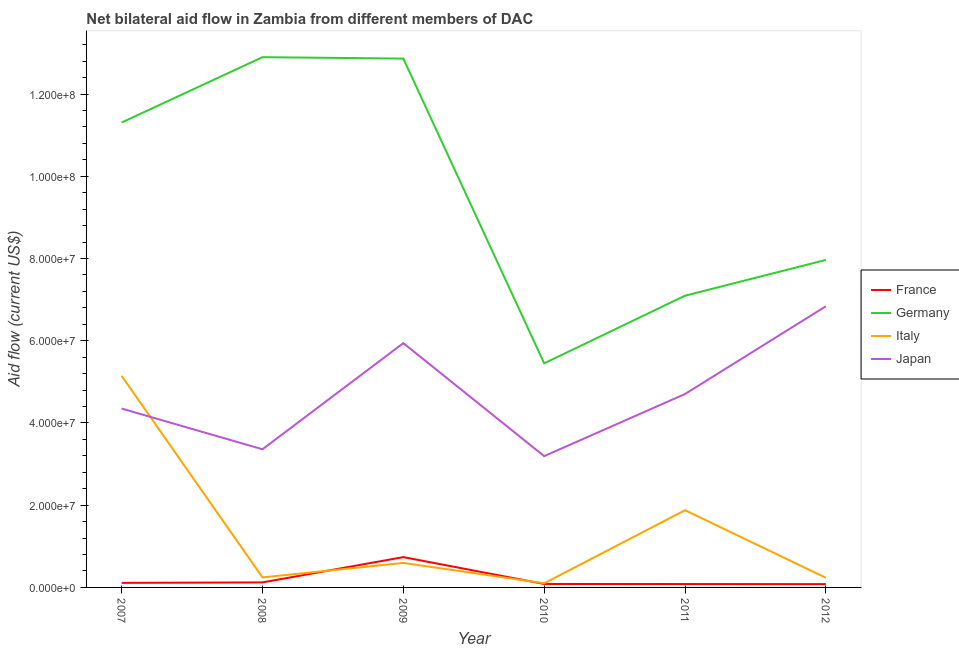How many different coloured lines are there?
Offer a terse response. 4. Does the line corresponding to amount of aid given by japan intersect with the line corresponding to amount of aid given by italy?
Provide a short and direct response. Yes. Is the number of lines equal to the number of legend labels?
Give a very brief answer. Yes. What is the amount of aid given by italy in 2007?
Provide a succinct answer. 5.14e+07. Across all years, what is the maximum amount of aid given by france?
Offer a very short reply. 7.37e+06. Across all years, what is the minimum amount of aid given by japan?
Keep it short and to the point. 3.19e+07. In which year was the amount of aid given by france maximum?
Offer a very short reply. 2009. In which year was the amount of aid given by japan minimum?
Your answer should be compact. 2010. What is the total amount of aid given by germany in the graph?
Offer a very short reply. 5.76e+08. What is the difference between the amount of aid given by germany in 2007 and that in 2011?
Keep it short and to the point. 4.21e+07. What is the difference between the amount of aid given by italy in 2012 and the amount of aid given by germany in 2007?
Offer a very short reply. -1.11e+08. What is the average amount of aid given by france per year?
Make the answer very short. 2.03e+06. In the year 2007, what is the difference between the amount of aid given by japan and amount of aid given by france?
Make the answer very short. 4.24e+07. What is the ratio of the amount of aid given by france in 2010 to that in 2011?
Provide a short and direct response. 1.02. Is the difference between the amount of aid given by italy in 2007 and 2011 greater than the difference between the amount of aid given by germany in 2007 and 2011?
Ensure brevity in your answer.  No. What is the difference between the highest and the second highest amount of aid given by italy?
Your answer should be very brief. 3.27e+07. What is the difference between the highest and the lowest amount of aid given by italy?
Give a very brief answer. 5.04e+07. In how many years, is the amount of aid given by france greater than the average amount of aid given by france taken over all years?
Make the answer very short. 1. Is the sum of the amount of aid given by germany in 2009 and 2011 greater than the maximum amount of aid given by italy across all years?
Give a very brief answer. Yes. Is the amount of aid given by japan strictly greater than the amount of aid given by italy over the years?
Ensure brevity in your answer.  No. Is the amount of aid given by italy strictly less than the amount of aid given by japan over the years?
Your response must be concise. No. How many lines are there?
Provide a short and direct response. 4. How many years are there in the graph?
Provide a succinct answer. 6. Are the values on the major ticks of Y-axis written in scientific E-notation?
Provide a short and direct response. Yes. Does the graph contain any zero values?
Provide a short and direct response. No. Does the graph contain grids?
Provide a succinct answer. No. How many legend labels are there?
Provide a succinct answer. 4. What is the title of the graph?
Your answer should be very brief. Net bilateral aid flow in Zambia from different members of DAC. What is the Aid flow (current US$) in France in 2007?
Your answer should be compact. 1.11e+06. What is the Aid flow (current US$) in Germany in 2007?
Provide a short and direct response. 1.13e+08. What is the Aid flow (current US$) of Italy in 2007?
Keep it short and to the point. 5.14e+07. What is the Aid flow (current US$) of Japan in 2007?
Ensure brevity in your answer.  4.35e+07. What is the Aid flow (current US$) of France in 2008?
Keep it short and to the point. 1.22e+06. What is the Aid flow (current US$) of Germany in 2008?
Ensure brevity in your answer.  1.29e+08. What is the Aid flow (current US$) of Italy in 2008?
Ensure brevity in your answer.  2.44e+06. What is the Aid flow (current US$) of Japan in 2008?
Your response must be concise. 3.36e+07. What is the Aid flow (current US$) in France in 2009?
Your answer should be very brief. 7.37e+06. What is the Aid flow (current US$) in Germany in 2009?
Keep it short and to the point. 1.29e+08. What is the Aid flow (current US$) in Italy in 2009?
Make the answer very short. 5.96e+06. What is the Aid flow (current US$) of Japan in 2009?
Provide a short and direct response. 5.94e+07. What is the Aid flow (current US$) of France in 2010?
Offer a very short reply. 8.40e+05. What is the Aid flow (current US$) of Germany in 2010?
Offer a very short reply. 5.45e+07. What is the Aid flow (current US$) of Italy in 2010?
Make the answer very short. 1.00e+06. What is the Aid flow (current US$) in Japan in 2010?
Your answer should be compact. 3.19e+07. What is the Aid flow (current US$) of France in 2011?
Your response must be concise. 8.20e+05. What is the Aid flow (current US$) of Germany in 2011?
Provide a succinct answer. 7.10e+07. What is the Aid flow (current US$) of Italy in 2011?
Your answer should be compact. 1.88e+07. What is the Aid flow (current US$) of Japan in 2011?
Offer a terse response. 4.70e+07. What is the Aid flow (current US$) of Germany in 2012?
Your response must be concise. 7.96e+07. What is the Aid flow (current US$) in Italy in 2012?
Provide a succinct answer. 2.34e+06. What is the Aid flow (current US$) of Japan in 2012?
Your answer should be very brief. 6.84e+07. Across all years, what is the maximum Aid flow (current US$) in France?
Provide a short and direct response. 7.37e+06. Across all years, what is the maximum Aid flow (current US$) in Germany?
Provide a short and direct response. 1.29e+08. Across all years, what is the maximum Aid flow (current US$) of Italy?
Make the answer very short. 5.14e+07. Across all years, what is the maximum Aid flow (current US$) in Japan?
Make the answer very short. 6.84e+07. Across all years, what is the minimum Aid flow (current US$) in Germany?
Provide a succinct answer. 5.45e+07. Across all years, what is the minimum Aid flow (current US$) in Italy?
Offer a terse response. 1.00e+06. Across all years, what is the minimum Aid flow (current US$) in Japan?
Offer a terse response. 3.19e+07. What is the total Aid flow (current US$) in France in the graph?
Your answer should be very brief. 1.22e+07. What is the total Aid flow (current US$) of Germany in the graph?
Give a very brief answer. 5.76e+08. What is the total Aid flow (current US$) of Italy in the graph?
Ensure brevity in your answer.  8.20e+07. What is the total Aid flow (current US$) in Japan in the graph?
Provide a short and direct response. 2.84e+08. What is the difference between the Aid flow (current US$) of Germany in 2007 and that in 2008?
Offer a very short reply. -1.59e+07. What is the difference between the Aid flow (current US$) in Italy in 2007 and that in 2008?
Keep it short and to the point. 4.90e+07. What is the difference between the Aid flow (current US$) of Japan in 2007 and that in 2008?
Offer a terse response. 9.90e+06. What is the difference between the Aid flow (current US$) of France in 2007 and that in 2009?
Give a very brief answer. -6.26e+06. What is the difference between the Aid flow (current US$) in Germany in 2007 and that in 2009?
Offer a terse response. -1.56e+07. What is the difference between the Aid flow (current US$) of Italy in 2007 and that in 2009?
Offer a very short reply. 4.55e+07. What is the difference between the Aid flow (current US$) of Japan in 2007 and that in 2009?
Ensure brevity in your answer.  -1.59e+07. What is the difference between the Aid flow (current US$) in France in 2007 and that in 2010?
Your response must be concise. 2.70e+05. What is the difference between the Aid flow (current US$) of Germany in 2007 and that in 2010?
Your answer should be compact. 5.86e+07. What is the difference between the Aid flow (current US$) in Italy in 2007 and that in 2010?
Your answer should be very brief. 5.04e+07. What is the difference between the Aid flow (current US$) of Japan in 2007 and that in 2010?
Your answer should be very brief. 1.16e+07. What is the difference between the Aid flow (current US$) of France in 2007 and that in 2011?
Provide a succinct answer. 2.90e+05. What is the difference between the Aid flow (current US$) of Germany in 2007 and that in 2011?
Provide a short and direct response. 4.21e+07. What is the difference between the Aid flow (current US$) of Italy in 2007 and that in 2011?
Your answer should be compact. 3.27e+07. What is the difference between the Aid flow (current US$) in Japan in 2007 and that in 2011?
Give a very brief answer. -3.54e+06. What is the difference between the Aid flow (current US$) of Germany in 2007 and that in 2012?
Offer a very short reply. 3.34e+07. What is the difference between the Aid flow (current US$) of Italy in 2007 and that in 2012?
Your answer should be compact. 4.91e+07. What is the difference between the Aid flow (current US$) in Japan in 2007 and that in 2012?
Your answer should be very brief. -2.49e+07. What is the difference between the Aid flow (current US$) of France in 2008 and that in 2009?
Your answer should be very brief. -6.15e+06. What is the difference between the Aid flow (current US$) in Italy in 2008 and that in 2009?
Provide a short and direct response. -3.52e+06. What is the difference between the Aid flow (current US$) in Japan in 2008 and that in 2009?
Offer a very short reply. -2.58e+07. What is the difference between the Aid flow (current US$) of France in 2008 and that in 2010?
Your answer should be compact. 3.80e+05. What is the difference between the Aid flow (current US$) in Germany in 2008 and that in 2010?
Provide a short and direct response. 7.45e+07. What is the difference between the Aid flow (current US$) in Italy in 2008 and that in 2010?
Ensure brevity in your answer.  1.44e+06. What is the difference between the Aid flow (current US$) of Japan in 2008 and that in 2010?
Provide a short and direct response. 1.67e+06. What is the difference between the Aid flow (current US$) in Germany in 2008 and that in 2011?
Provide a short and direct response. 5.80e+07. What is the difference between the Aid flow (current US$) in Italy in 2008 and that in 2011?
Your answer should be compact. -1.63e+07. What is the difference between the Aid flow (current US$) of Japan in 2008 and that in 2011?
Offer a very short reply. -1.34e+07. What is the difference between the Aid flow (current US$) of Germany in 2008 and that in 2012?
Your answer should be very brief. 4.93e+07. What is the difference between the Aid flow (current US$) in Japan in 2008 and that in 2012?
Your response must be concise. -3.48e+07. What is the difference between the Aid flow (current US$) of France in 2009 and that in 2010?
Give a very brief answer. 6.53e+06. What is the difference between the Aid flow (current US$) in Germany in 2009 and that in 2010?
Ensure brevity in your answer.  7.41e+07. What is the difference between the Aid flow (current US$) of Italy in 2009 and that in 2010?
Ensure brevity in your answer.  4.96e+06. What is the difference between the Aid flow (current US$) in Japan in 2009 and that in 2010?
Your answer should be compact. 2.75e+07. What is the difference between the Aid flow (current US$) in France in 2009 and that in 2011?
Provide a short and direct response. 6.55e+06. What is the difference between the Aid flow (current US$) in Germany in 2009 and that in 2011?
Ensure brevity in your answer.  5.77e+07. What is the difference between the Aid flow (current US$) in Italy in 2009 and that in 2011?
Keep it short and to the point. -1.28e+07. What is the difference between the Aid flow (current US$) in Japan in 2009 and that in 2011?
Ensure brevity in your answer.  1.24e+07. What is the difference between the Aid flow (current US$) of France in 2009 and that in 2012?
Offer a very short reply. 6.57e+06. What is the difference between the Aid flow (current US$) of Germany in 2009 and that in 2012?
Your answer should be very brief. 4.90e+07. What is the difference between the Aid flow (current US$) of Italy in 2009 and that in 2012?
Offer a very short reply. 3.62e+06. What is the difference between the Aid flow (current US$) in Japan in 2009 and that in 2012?
Give a very brief answer. -8.97e+06. What is the difference between the Aid flow (current US$) in France in 2010 and that in 2011?
Keep it short and to the point. 2.00e+04. What is the difference between the Aid flow (current US$) in Germany in 2010 and that in 2011?
Provide a short and direct response. -1.64e+07. What is the difference between the Aid flow (current US$) in Italy in 2010 and that in 2011?
Provide a succinct answer. -1.78e+07. What is the difference between the Aid flow (current US$) of Japan in 2010 and that in 2011?
Your response must be concise. -1.51e+07. What is the difference between the Aid flow (current US$) of France in 2010 and that in 2012?
Offer a terse response. 4.00e+04. What is the difference between the Aid flow (current US$) of Germany in 2010 and that in 2012?
Provide a short and direct response. -2.52e+07. What is the difference between the Aid flow (current US$) in Italy in 2010 and that in 2012?
Make the answer very short. -1.34e+06. What is the difference between the Aid flow (current US$) of Japan in 2010 and that in 2012?
Provide a short and direct response. -3.64e+07. What is the difference between the Aid flow (current US$) of France in 2011 and that in 2012?
Keep it short and to the point. 2.00e+04. What is the difference between the Aid flow (current US$) of Germany in 2011 and that in 2012?
Your answer should be compact. -8.70e+06. What is the difference between the Aid flow (current US$) of Italy in 2011 and that in 2012?
Your answer should be compact. 1.64e+07. What is the difference between the Aid flow (current US$) in Japan in 2011 and that in 2012?
Provide a succinct answer. -2.13e+07. What is the difference between the Aid flow (current US$) in France in 2007 and the Aid flow (current US$) in Germany in 2008?
Offer a very short reply. -1.28e+08. What is the difference between the Aid flow (current US$) in France in 2007 and the Aid flow (current US$) in Italy in 2008?
Ensure brevity in your answer.  -1.33e+06. What is the difference between the Aid flow (current US$) in France in 2007 and the Aid flow (current US$) in Japan in 2008?
Your answer should be very brief. -3.25e+07. What is the difference between the Aid flow (current US$) in Germany in 2007 and the Aid flow (current US$) in Italy in 2008?
Your answer should be compact. 1.11e+08. What is the difference between the Aid flow (current US$) in Germany in 2007 and the Aid flow (current US$) in Japan in 2008?
Your response must be concise. 7.95e+07. What is the difference between the Aid flow (current US$) in Italy in 2007 and the Aid flow (current US$) in Japan in 2008?
Your answer should be compact. 1.78e+07. What is the difference between the Aid flow (current US$) in France in 2007 and the Aid flow (current US$) in Germany in 2009?
Give a very brief answer. -1.28e+08. What is the difference between the Aid flow (current US$) in France in 2007 and the Aid flow (current US$) in Italy in 2009?
Your response must be concise. -4.85e+06. What is the difference between the Aid flow (current US$) in France in 2007 and the Aid flow (current US$) in Japan in 2009?
Give a very brief answer. -5.83e+07. What is the difference between the Aid flow (current US$) of Germany in 2007 and the Aid flow (current US$) of Italy in 2009?
Your answer should be very brief. 1.07e+08. What is the difference between the Aid flow (current US$) of Germany in 2007 and the Aid flow (current US$) of Japan in 2009?
Keep it short and to the point. 5.37e+07. What is the difference between the Aid flow (current US$) in Italy in 2007 and the Aid flow (current US$) in Japan in 2009?
Keep it short and to the point. -7.96e+06. What is the difference between the Aid flow (current US$) in France in 2007 and the Aid flow (current US$) in Germany in 2010?
Offer a terse response. -5.34e+07. What is the difference between the Aid flow (current US$) in France in 2007 and the Aid flow (current US$) in Japan in 2010?
Your response must be concise. -3.08e+07. What is the difference between the Aid flow (current US$) of Germany in 2007 and the Aid flow (current US$) of Italy in 2010?
Give a very brief answer. 1.12e+08. What is the difference between the Aid flow (current US$) in Germany in 2007 and the Aid flow (current US$) in Japan in 2010?
Provide a short and direct response. 8.11e+07. What is the difference between the Aid flow (current US$) of Italy in 2007 and the Aid flow (current US$) of Japan in 2010?
Ensure brevity in your answer.  1.95e+07. What is the difference between the Aid flow (current US$) in France in 2007 and the Aid flow (current US$) in Germany in 2011?
Your response must be concise. -6.98e+07. What is the difference between the Aid flow (current US$) of France in 2007 and the Aid flow (current US$) of Italy in 2011?
Your answer should be compact. -1.77e+07. What is the difference between the Aid flow (current US$) of France in 2007 and the Aid flow (current US$) of Japan in 2011?
Provide a short and direct response. -4.59e+07. What is the difference between the Aid flow (current US$) of Germany in 2007 and the Aid flow (current US$) of Italy in 2011?
Your answer should be very brief. 9.43e+07. What is the difference between the Aid flow (current US$) of Germany in 2007 and the Aid flow (current US$) of Japan in 2011?
Keep it short and to the point. 6.60e+07. What is the difference between the Aid flow (current US$) of Italy in 2007 and the Aid flow (current US$) of Japan in 2011?
Your answer should be very brief. 4.41e+06. What is the difference between the Aid flow (current US$) of France in 2007 and the Aid flow (current US$) of Germany in 2012?
Offer a very short reply. -7.85e+07. What is the difference between the Aid flow (current US$) of France in 2007 and the Aid flow (current US$) of Italy in 2012?
Provide a succinct answer. -1.23e+06. What is the difference between the Aid flow (current US$) in France in 2007 and the Aid flow (current US$) in Japan in 2012?
Make the answer very short. -6.73e+07. What is the difference between the Aid flow (current US$) in Germany in 2007 and the Aid flow (current US$) in Italy in 2012?
Offer a very short reply. 1.11e+08. What is the difference between the Aid flow (current US$) of Germany in 2007 and the Aid flow (current US$) of Japan in 2012?
Provide a succinct answer. 4.47e+07. What is the difference between the Aid flow (current US$) in Italy in 2007 and the Aid flow (current US$) in Japan in 2012?
Your answer should be very brief. -1.69e+07. What is the difference between the Aid flow (current US$) in France in 2008 and the Aid flow (current US$) in Germany in 2009?
Your answer should be compact. -1.27e+08. What is the difference between the Aid flow (current US$) in France in 2008 and the Aid flow (current US$) in Italy in 2009?
Keep it short and to the point. -4.74e+06. What is the difference between the Aid flow (current US$) in France in 2008 and the Aid flow (current US$) in Japan in 2009?
Offer a very short reply. -5.82e+07. What is the difference between the Aid flow (current US$) in Germany in 2008 and the Aid flow (current US$) in Italy in 2009?
Provide a succinct answer. 1.23e+08. What is the difference between the Aid flow (current US$) of Germany in 2008 and the Aid flow (current US$) of Japan in 2009?
Keep it short and to the point. 6.96e+07. What is the difference between the Aid flow (current US$) of Italy in 2008 and the Aid flow (current US$) of Japan in 2009?
Offer a terse response. -5.70e+07. What is the difference between the Aid flow (current US$) in France in 2008 and the Aid flow (current US$) in Germany in 2010?
Give a very brief answer. -5.33e+07. What is the difference between the Aid flow (current US$) of France in 2008 and the Aid flow (current US$) of Japan in 2010?
Your response must be concise. -3.07e+07. What is the difference between the Aid flow (current US$) in Germany in 2008 and the Aid flow (current US$) in Italy in 2010?
Your answer should be compact. 1.28e+08. What is the difference between the Aid flow (current US$) of Germany in 2008 and the Aid flow (current US$) of Japan in 2010?
Make the answer very short. 9.70e+07. What is the difference between the Aid flow (current US$) of Italy in 2008 and the Aid flow (current US$) of Japan in 2010?
Make the answer very short. -2.95e+07. What is the difference between the Aid flow (current US$) of France in 2008 and the Aid flow (current US$) of Germany in 2011?
Offer a very short reply. -6.97e+07. What is the difference between the Aid flow (current US$) of France in 2008 and the Aid flow (current US$) of Italy in 2011?
Offer a terse response. -1.76e+07. What is the difference between the Aid flow (current US$) in France in 2008 and the Aid flow (current US$) in Japan in 2011?
Ensure brevity in your answer.  -4.58e+07. What is the difference between the Aid flow (current US$) of Germany in 2008 and the Aid flow (current US$) of Italy in 2011?
Your answer should be compact. 1.10e+08. What is the difference between the Aid flow (current US$) in Germany in 2008 and the Aid flow (current US$) in Japan in 2011?
Ensure brevity in your answer.  8.19e+07. What is the difference between the Aid flow (current US$) of Italy in 2008 and the Aid flow (current US$) of Japan in 2011?
Offer a very short reply. -4.46e+07. What is the difference between the Aid flow (current US$) of France in 2008 and the Aid flow (current US$) of Germany in 2012?
Your answer should be compact. -7.84e+07. What is the difference between the Aid flow (current US$) of France in 2008 and the Aid flow (current US$) of Italy in 2012?
Provide a succinct answer. -1.12e+06. What is the difference between the Aid flow (current US$) in France in 2008 and the Aid flow (current US$) in Japan in 2012?
Your answer should be compact. -6.72e+07. What is the difference between the Aid flow (current US$) in Germany in 2008 and the Aid flow (current US$) in Italy in 2012?
Your answer should be very brief. 1.27e+08. What is the difference between the Aid flow (current US$) in Germany in 2008 and the Aid flow (current US$) in Japan in 2012?
Keep it short and to the point. 6.06e+07. What is the difference between the Aid flow (current US$) of Italy in 2008 and the Aid flow (current US$) of Japan in 2012?
Your answer should be very brief. -6.59e+07. What is the difference between the Aid flow (current US$) in France in 2009 and the Aid flow (current US$) in Germany in 2010?
Provide a short and direct response. -4.71e+07. What is the difference between the Aid flow (current US$) of France in 2009 and the Aid flow (current US$) of Italy in 2010?
Ensure brevity in your answer.  6.37e+06. What is the difference between the Aid flow (current US$) of France in 2009 and the Aid flow (current US$) of Japan in 2010?
Provide a short and direct response. -2.46e+07. What is the difference between the Aid flow (current US$) in Germany in 2009 and the Aid flow (current US$) in Italy in 2010?
Your answer should be compact. 1.28e+08. What is the difference between the Aid flow (current US$) of Germany in 2009 and the Aid flow (current US$) of Japan in 2010?
Make the answer very short. 9.67e+07. What is the difference between the Aid flow (current US$) of Italy in 2009 and the Aid flow (current US$) of Japan in 2010?
Your answer should be very brief. -2.60e+07. What is the difference between the Aid flow (current US$) in France in 2009 and the Aid flow (current US$) in Germany in 2011?
Provide a short and direct response. -6.36e+07. What is the difference between the Aid flow (current US$) of France in 2009 and the Aid flow (current US$) of Italy in 2011?
Provide a succinct answer. -1.14e+07. What is the difference between the Aid flow (current US$) of France in 2009 and the Aid flow (current US$) of Japan in 2011?
Provide a short and direct response. -3.97e+07. What is the difference between the Aid flow (current US$) in Germany in 2009 and the Aid flow (current US$) in Italy in 2011?
Your answer should be very brief. 1.10e+08. What is the difference between the Aid flow (current US$) of Germany in 2009 and the Aid flow (current US$) of Japan in 2011?
Ensure brevity in your answer.  8.16e+07. What is the difference between the Aid flow (current US$) of Italy in 2009 and the Aid flow (current US$) of Japan in 2011?
Your answer should be very brief. -4.11e+07. What is the difference between the Aid flow (current US$) of France in 2009 and the Aid flow (current US$) of Germany in 2012?
Your answer should be very brief. -7.23e+07. What is the difference between the Aid flow (current US$) of France in 2009 and the Aid flow (current US$) of Italy in 2012?
Your answer should be compact. 5.03e+06. What is the difference between the Aid flow (current US$) of France in 2009 and the Aid flow (current US$) of Japan in 2012?
Keep it short and to the point. -6.10e+07. What is the difference between the Aid flow (current US$) of Germany in 2009 and the Aid flow (current US$) of Italy in 2012?
Your answer should be compact. 1.26e+08. What is the difference between the Aid flow (current US$) of Germany in 2009 and the Aid flow (current US$) of Japan in 2012?
Keep it short and to the point. 6.02e+07. What is the difference between the Aid flow (current US$) in Italy in 2009 and the Aid flow (current US$) in Japan in 2012?
Offer a very short reply. -6.24e+07. What is the difference between the Aid flow (current US$) in France in 2010 and the Aid flow (current US$) in Germany in 2011?
Provide a succinct answer. -7.01e+07. What is the difference between the Aid flow (current US$) in France in 2010 and the Aid flow (current US$) in Italy in 2011?
Provide a short and direct response. -1.79e+07. What is the difference between the Aid flow (current US$) in France in 2010 and the Aid flow (current US$) in Japan in 2011?
Make the answer very short. -4.62e+07. What is the difference between the Aid flow (current US$) of Germany in 2010 and the Aid flow (current US$) of Italy in 2011?
Provide a succinct answer. 3.57e+07. What is the difference between the Aid flow (current US$) of Germany in 2010 and the Aid flow (current US$) of Japan in 2011?
Give a very brief answer. 7.46e+06. What is the difference between the Aid flow (current US$) in Italy in 2010 and the Aid flow (current US$) in Japan in 2011?
Offer a terse response. -4.60e+07. What is the difference between the Aid flow (current US$) of France in 2010 and the Aid flow (current US$) of Germany in 2012?
Give a very brief answer. -7.88e+07. What is the difference between the Aid flow (current US$) of France in 2010 and the Aid flow (current US$) of Italy in 2012?
Your answer should be compact. -1.50e+06. What is the difference between the Aid flow (current US$) of France in 2010 and the Aid flow (current US$) of Japan in 2012?
Ensure brevity in your answer.  -6.75e+07. What is the difference between the Aid flow (current US$) of Germany in 2010 and the Aid flow (current US$) of Italy in 2012?
Ensure brevity in your answer.  5.22e+07. What is the difference between the Aid flow (current US$) in Germany in 2010 and the Aid flow (current US$) in Japan in 2012?
Keep it short and to the point. -1.39e+07. What is the difference between the Aid flow (current US$) in Italy in 2010 and the Aid flow (current US$) in Japan in 2012?
Give a very brief answer. -6.74e+07. What is the difference between the Aid flow (current US$) in France in 2011 and the Aid flow (current US$) in Germany in 2012?
Make the answer very short. -7.88e+07. What is the difference between the Aid flow (current US$) in France in 2011 and the Aid flow (current US$) in Italy in 2012?
Your answer should be very brief. -1.52e+06. What is the difference between the Aid flow (current US$) in France in 2011 and the Aid flow (current US$) in Japan in 2012?
Offer a very short reply. -6.76e+07. What is the difference between the Aid flow (current US$) of Germany in 2011 and the Aid flow (current US$) of Italy in 2012?
Offer a very short reply. 6.86e+07. What is the difference between the Aid flow (current US$) in Germany in 2011 and the Aid flow (current US$) in Japan in 2012?
Your answer should be very brief. 2.57e+06. What is the difference between the Aid flow (current US$) in Italy in 2011 and the Aid flow (current US$) in Japan in 2012?
Provide a succinct answer. -4.96e+07. What is the average Aid flow (current US$) in France per year?
Your response must be concise. 2.03e+06. What is the average Aid flow (current US$) in Germany per year?
Provide a short and direct response. 9.60e+07. What is the average Aid flow (current US$) of Italy per year?
Your response must be concise. 1.37e+07. What is the average Aid flow (current US$) of Japan per year?
Give a very brief answer. 4.73e+07. In the year 2007, what is the difference between the Aid flow (current US$) of France and Aid flow (current US$) of Germany?
Your response must be concise. -1.12e+08. In the year 2007, what is the difference between the Aid flow (current US$) in France and Aid flow (current US$) in Italy?
Keep it short and to the point. -5.03e+07. In the year 2007, what is the difference between the Aid flow (current US$) of France and Aid flow (current US$) of Japan?
Give a very brief answer. -4.24e+07. In the year 2007, what is the difference between the Aid flow (current US$) in Germany and Aid flow (current US$) in Italy?
Your answer should be compact. 6.16e+07. In the year 2007, what is the difference between the Aid flow (current US$) in Germany and Aid flow (current US$) in Japan?
Your answer should be compact. 6.96e+07. In the year 2007, what is the difference between the Aid flow (current US$) in Italy and Aid flow (current US$) in Japan?
Give a very brief answer. 7.95e+06. In the year 2008, what is the difference between the Aid flow (current US$) in France and Aid flow (current US$) in Germany?
Make the answer very short. -1.28e+08. In the year 2008, what is the difference between the Aid flow (current US$) of France and Aid flow (current US$) of Italy?
Provide a short and direct response. -1.22e+06. In the year 2008, what is the difference between the Aid flow (current US$) of France and Aid flow (current US$) of Japan?
Provide a short and direct response. -3.24e+07. In the year 2008, what is the difference between the Aid flow (current US$) of Germany and Aid flow (current US$) of Italy?
Your answer should be compact. 1.27e+08. In the year 2008, what is the difference between the Aid flow (current US$) of Germany and Aid flow (current US$) of Japan?
Offer a terse response. 9.54e+07. In the year 2008, what is the difference between the Aid flow (current US$) of Italy and Aid flow (current US$) of Japan?
Keep it short and to the point. -3.12e+07. In the year 2009, what is the difference between the Aid flow (current US$) of France and Aid flow (current US$) of Germany?
Provide a succinct answer. -1.21e+08. In the year 2009, what is the difference between the Aid flow (current US$) of France and Aid flow (current US$) of Italy?
Offer a terse response. 1.41e+06. In the year 2009, what is the difference between the Aid flow (current US$) of France and Aid flow (current US$) of Japan?
Give a very brief answer. -5.20e+07. In the year 2009, what is the difference between the Aid flow (current US$) of Germany and Aid flow (current US$) of Italy?
Provide a short and direct response. 1.23e+08. In the year 2009, what is the difference between the Aid flow (current US$) in Germany and Aid flow (current US$) in Japan?
Your answer should be very brief. 6.92e+07. In the year 2009, what is the difference between the Aid flow (current US$) of Italy and Aid flow (current US$) of Japan?
Offer a terse response. -5.34e+07. In the year 2010, what is the difference between the Aid flow (current US$) in France and Aid flow (current US$) in Germany?
Ensure brevity in your answer.  -5.37e+07. In the year 2010, what is the difference between the Aid flow (current US$) in France and Aid flow (current US$) in Japan?
Offer a terse response. -3.11e+07. In the year 2010, what is the difference between the Aid flow (current US$) in Germany and Aid flow (current US$) in Italy?
Make the answer very short. 5.35e+07. In the year 2010, what is the difference between the Aid flow (current US$) of Germany and Aid flow (current US$) of Japan?
Keep it short and to the point. 2.26e+07. In the year 2010, what is the difference between the Aid flow (current US$) of Italy and Aid flow (current US$) of Japan?
Offer a terse response. -3.09e+07. In the year 2011, what is the difference between the Aid flow (current US$) of France and Aid flow (current US$) of Germany?
Your answer should be very brief. -7.01e+07. In the year 2011, what is the difference between the Aid flow (current US$) in France and Aid flow (current US$) in Italy?
Provide a short and direct response. -1.80e+07. In the year 2011, what is the difference between the Aid flow (current US$) in France and Aid flow (current US$) in Japan?
Give a very brief answer. -4.62e+07. In the year 2011, what is the difference between the Aid flow (current US$) in Germany and Aid flow (current US$) in Italy?
Your answer should be compact. 5.22e+07. In the year 2011, what is the difference between the Aid flow (current US$) of Germany and Aid flow (current US$) of Japan?
Your response must be concise. 2.39e+07. In the year 2011, what is the difference between the Aid flow (current US$) of Italy and Aid flow (current US$) of Japan?
Make the answer very short. -2.83e+07. In the year 2012, what is the difference between the Aid flow (current US$) in France and Aid flow (current US$) in Germany?
Keep it short and to the point. -7.88e+07. In the year 2012, what is the difference between the Aid flow (current US$) of France and Aid flow (current US$) of Italy?
Make the answer very short. -1.54e+06. In the year 2012, what is the difference between the Aid flow (current US$) in France and Aid flow (current US$) in Japan?
Ensure brevity in your answer.  -6.76e+07. In the year 2012, what is the difference between the Aid flow (current US$) in Germany and Aid flow (current US$) in Italy?
Give a very brief answer. 7.73e+07. In the year 2012, what is the difference between the Aid flow (current US$) of Germany and Aid flow (current US$) of Japan?
Provide a succinct answer. 1.13e+07. In the year 2012, what is the difference between the Aid flow (current US$) in Italy and Aid flow (current US$) in Japan?
Keep it short and to the point. -6.60e+07. What is the ratio of the Aid flow (current US$) of France in 2007 to that in 2008?
Ensure brevity in your answer.  0.91. What is the ratio of the Aid flow (current US$) in Germany in 2007 to that in 2008?
Provide a succinct answer. 0.88. What is the ratio of the Aid flow (current US$) in Italy in 2007 to that in 2008?
Your response must be concise. 21.09. What is the ratio of the Aid flow (current US$) in Japan in 2007 to that in 2008?
Provide a succinct answer. 1.29. What is the ratio of the Aid flow (current US$) of France in 2007 to that in 2009?
Your answer should be compact. 0.15. What is the ratio of the Aid flow (current US$) of Germany in 2007 to that in 2009?
Provide a succinct answer. 0.88. What is the ratio of the Aid flow (current US$) of Italy in 2007 to that in 2009?
Keep it short and to the point. 8.63. What is the ratio of the Aid flow (current US$) of Japan in 2007 to that in 2009?
Keep it short and to the point. 0.73. What is the ratio of the Aid flow (current US$) in France in 2007 to that in 2010?
Your answer should be very brief. 1.32. What is the ratio of the Aid flow (current US$) in Germany in 2007 to that in 2010?
Make the answer very short. 2.07. What is the ratio of the Aid flow (current US$) of Italy in 2007 to that in 2010?
Give a very brief answer. 51.45. What is the ratio of the Aid flow (current US$) of Japan in 2007 to that in 2010?
Offer a very short reply. 1.36. What is the ratio of the Aid flow (current US$) of France in 2007 to that in 2011?
Offer a very short reply. 1.35. What is the ratio of the Aid flow (current US$) of Germany in 2007 to that in 2011?
Provide a short and direct response. 1.59. What is the ratio of the Aid flow (current US$) in Italy in 2007 to that in 2011?
Give a very brief answer. 2.74. What is the ratio of the Aid flow (current US$) in Japan in 2007 to that in 2011?
Keep it short and to the point. 0.92. What is the ratio of the Aid flow (current US$) of France in 2007 to that in 2012?
Offer a terse response. 1.39. What is the ratio of the Aid flow (current US$) of Germany in 2007 to that in 2012?
Keep it short and to the point. 1.42. What is the ratio of the Aid flow (current US$) in Italy in 2007 to that in 2012?
Provide a succinct answer. 21.99. What is the ratio of the Aid flow (current US$) in Japan in 2007 to that in 2012?
Your answer should be very brief. 0.64. What is the ratio of the Aid flow (current US$) in France in 2008 to that in 2009?
Your answer should be compact. 0.17. What is the ratio of the Aid flow (current US$) of Germany in 2008 to that in 2009?
Give a very brief answer. 1. What is the ratio of the Aid flow (current US$) in Italy in 2008 to that in 2009?
Ensure brevity in your answer.  0.41. What is the ratio of the Aid flow (current US$) in Japan in 2008 to that in 2009?
Your answer should be compact. 0.57. What is the ratio of the Aid flow (current US$) of France in 2008 to that in 2010?
Your response must be concise. 1.45. What is the ratio of the Aid flow (current US$) in Germany in 2008 to that in 2010?
Your answer should be very brief. 2.37. What is the ratio of the Aid flow (current US$) in Italy in 2008 to that in 2010?
Make the answer very short. 2.44. What is the ratio of the Aid flow (current US$) in Japan in 2008 to that in 2010?
Offer a very short reply. 1.05. What is the ratio of the Aid flow (current US$) in France in 2008 to that in 2011?
Make the answer very short. 1.49. What is the ratio of the Aid flow (current US$) in Germany in 2008 to that in 2011?
Your answer should be very brief. 1.82. What is the ratio of the Aid flow (current US$) of Italy in 2008 to that in 2011?
Ensure brevity in your answer.  0.13. What is the ratio of the Aid flow (current US$) of Japan in 2008 to that in 2011?
Ensure brevity in your answer.  0.71. What is the ratio of the Aid flow (current US$) of France in 2008 to that in 2012?
Offer a terse response. 1.52. What is the ratio of the Aid flow (current US$) of Germany in 2008 to that in 2012?
Keep it short and to the point. 1.62. What is the ratio of the Aid flow (current US$) of Italy in 2008 to that in 2012?
Make the answer very short. 1.04. What is the ratio of the Aid flow (current US$) in Japan in 2008 to that in 2012?
Offer a terse response. 0.49. What is the ratio of the Aid flow (current US$) of France in 2009 to that in 2010?
Offer a terse response. 8.77. What is the ratio of the Aid flow (current US$) in Germany in 2009 to that in 2010?
Your response must be concise. 2.36. What is the ratio of the Aid flow (current US$) of Italy in 2009 to that in 2010?
Keep it short and to the point. 5.96. What is the ratio of the Aid flow (current US$) in Japan in 2009 to that in 2010?
Provide a short and direct response. 1.86. What is the ratio of the Aid flow (current US$) in France in 2009 to that in 2011?
Offer a terse response. 8.99. What is the ratio of the Aid flow (current US$) in Germany in 2009 to that in 2011?
Your response must be concise. 1.81. What is the ratio of the Aid flow (current US$) of Italy in 2009 to that in 2011?
Your answer should be very brief. 0.32. What is the ratio of the Aid flow (current US$) of Japan in 2009 to that in 2011?
Provide a succinct answer. 1.26. What is the ratio of the Aid flow (current US$) of France in 2009 to that in 2012?
Keep it short and to the point. 9.21. What is the ratio of the Aid flow (current US$) in Germany in 2009 to that in 2012?
Your answer should be very brief. 1.61. What is the ratio of the Aid flow (current US$) of Italy in 2009 to that in 2012?
Give a very brief answer. 2.55. What is the ratio of the Aid flow (current US$) in Japan in 2009 to that in 2012?
Offer a very short reply. 0.87. What is the ratio of the Aid flow (current US$) of France in 2010 to that in 2011?
Provide a succinct answer. 1.02. What is the ratio of the Aid flow (current US$) of Germany in 2010 to that in 2011?
Your answer should be compact. 0.77. What is the ratio of the Aid flow (current US$) of Italy in 2010 to that in 2011?
Ensure brevity in your answer.  0.05. What is the ratio of the Aid flow (current US$) in Japan in 2010 to that in 2011?
Your answer should be compact. 0.68. What is the ratio of the Aid flow (current US$) of France in 2010 to that in 2012?
Your answer should be very brief. 1.05. What is the ratio of the Aid flow (current US$) of Germany in 2010 to that in 2012?
Offer a very short reply. 0.68. What is the ratio of the Aid flow (current US$) in Italy in 2010 to that in 2012?
Keep it short and to the point. 0.43. What is the ratio of the Aid flow (current US$) in Japan in 2010 to that in 2012?
Your answer should be very brief. 0.47. What is the ratio of the Aid flow (current US$) of France in 2011 to that in 2012?
Your answer should be very brief. 1.02. What is the ratio of the Aid flow (current US$) in Germany in 2011 to that in 2012?
Ensure brevity in your answer.  0.89. What is the ratio of the Aid flow (current US$) of Italy in 2011 to that in 2012?
Offer a very short reply. 8.03. What is the ratio of the Aid flow (current US$) of Japan in 2011 to that in 2012?
Your answer should be very brief. 0.69. What is the difference between the highest and the second highest Aid flow (current US$) in France?
Provide a succinct answer. 6.15e+06. What is the difference between the highest and the second highest Aid flow (current US$) in Germany?
Your answer should be very brief. 3.40e+05. What is the difference between the highest and the second highest Aid flow (current US$) of Italy?
Give a very brief answer. 3.27e+07. What is the difference between the highest and the second highest Aid flow (current US$) in Japan?
Your response must be concise. 8.97e+06. What is the difference between the highest and the lowest Aid flow (current US$) in France?
Provide a succinct answer. 6.57e+06. What is the difference between the highest and the lowest Aid flow (current US$) in Germany?
Keep it short and to the point. 7.45e+07. What is the difference between the highest and the lowest Aid flow (current US$) of Italy?
Your response must be concise. 5.04e+07. What is the difference between the highest and the lowest Aid flow (current US$) of Japan?
Make the answer very short. 3.64e+07. 